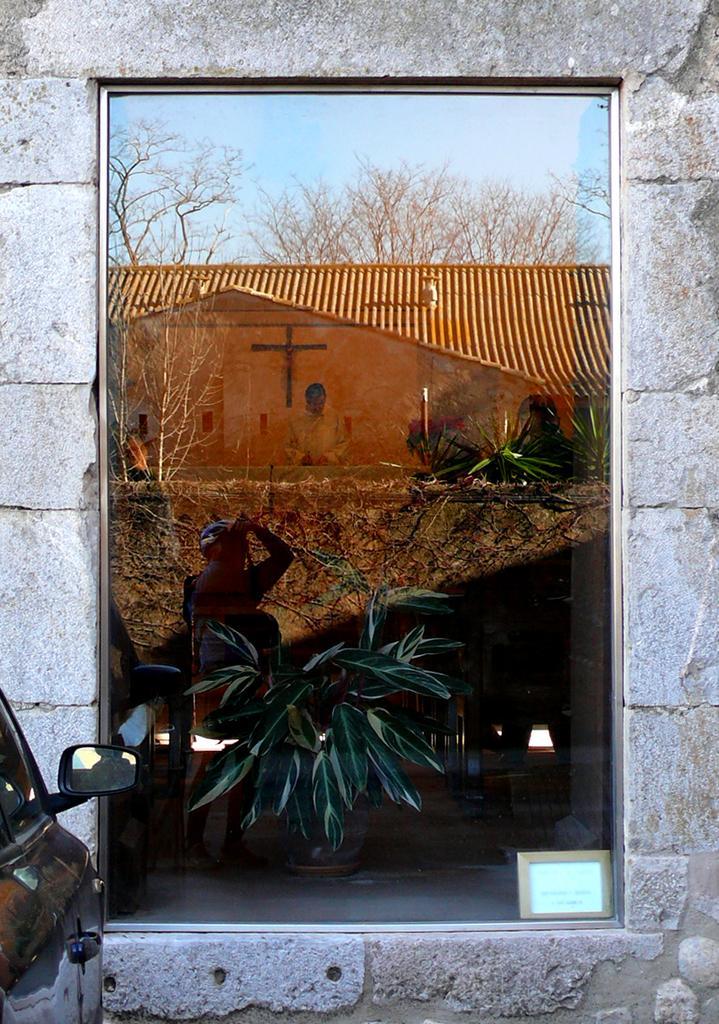Please provide a concise description of this image. This is the picture of a building. In the mirror there is a reflection of a person, building, trees and sky. On the left side of the image there is a vehicle. 